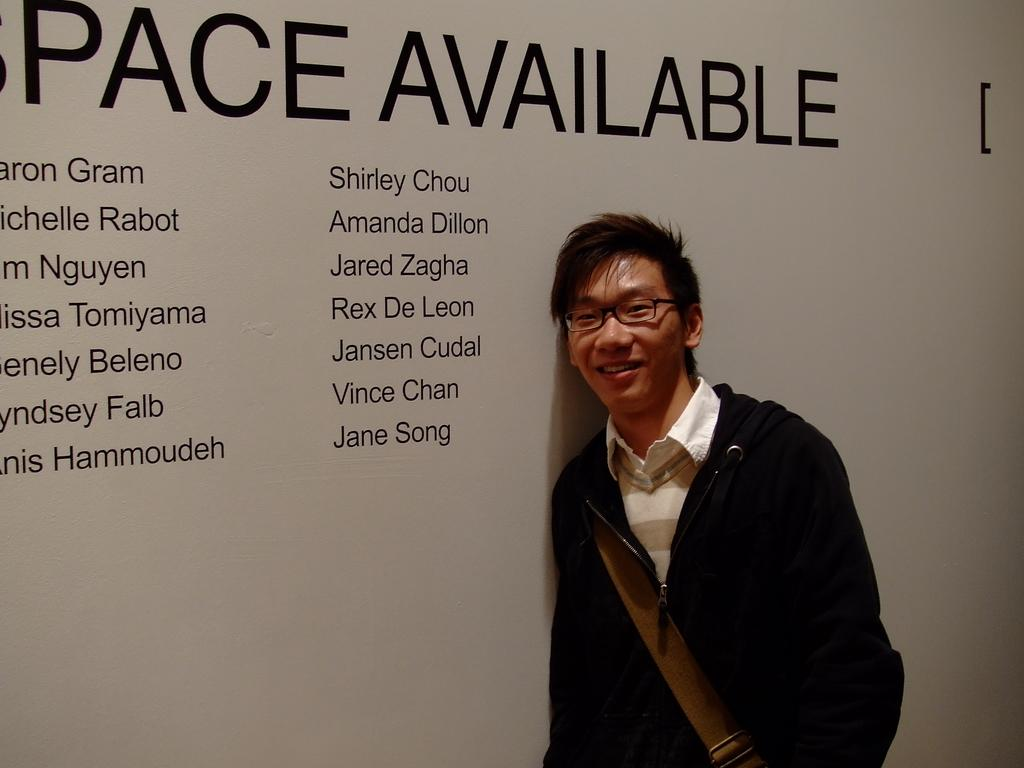What is the main subject of the image? There is a person in the image. Can you describe the person's appearance? The person is wearing spectacles and is smiling. Where might the person be standing in the image? The person may be standing in front of a wall. What can be seen on the wall? There is text on the wall. What type of oatmeal is being served on the wall in the image? There is no oatmeal present in the image; it features a person standing in front of a wall with text on it. How many plants are visible in the image? There are no plants visible in the image. 